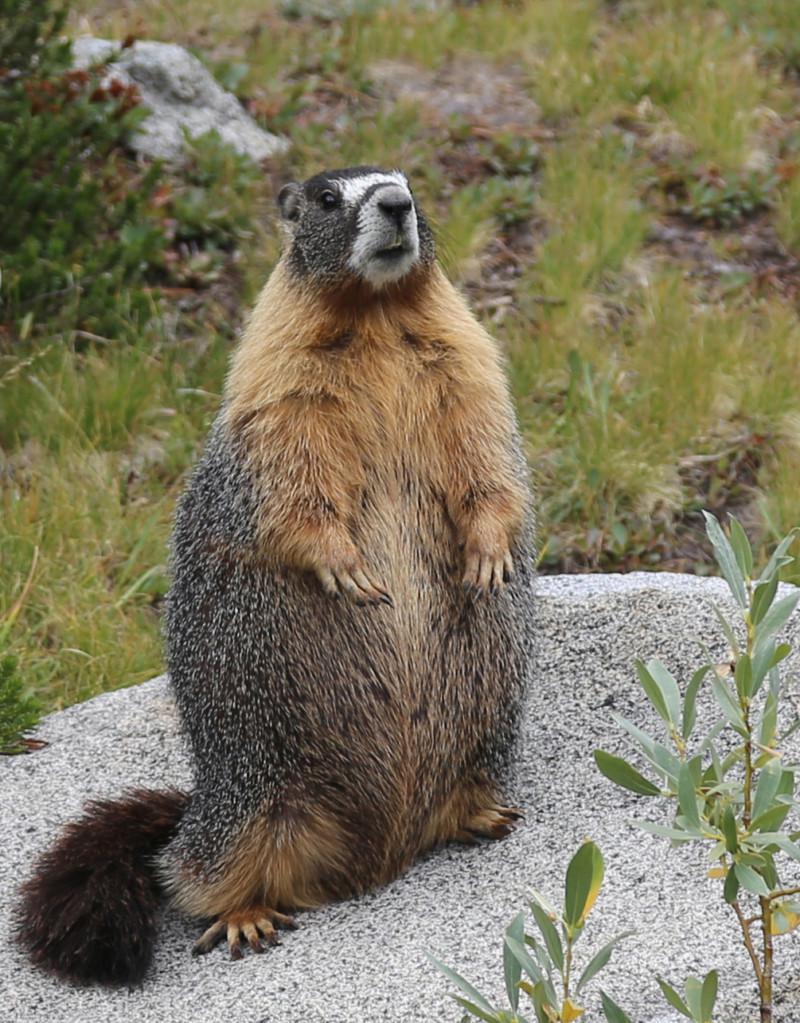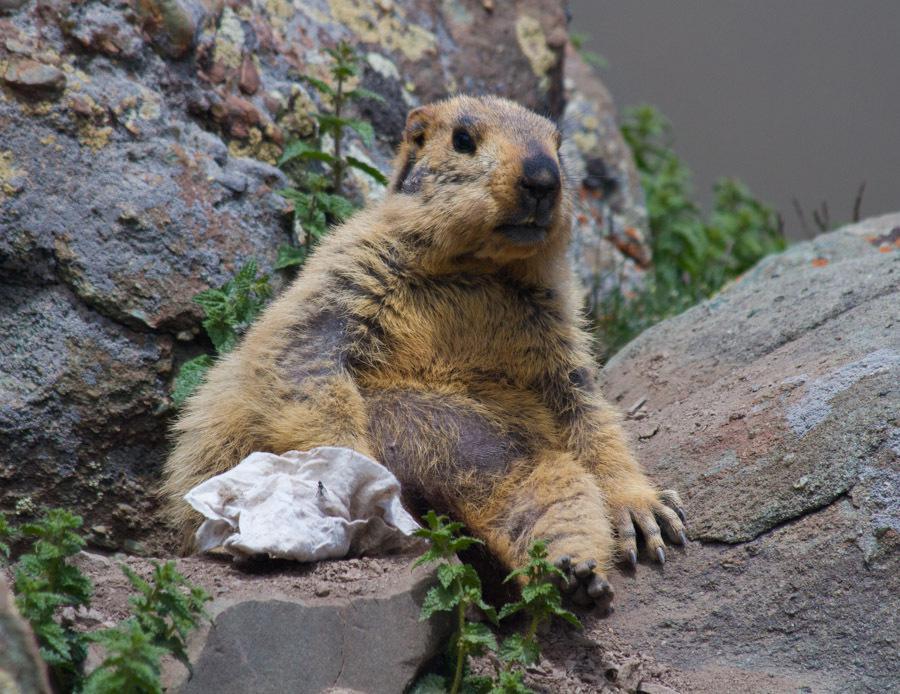The first image is the image on the left, the second image is the image on the right. For the images shown, is this caption "The animal in the image on the right is on some form of vegetation." true? Answer yes or no. Yes. 